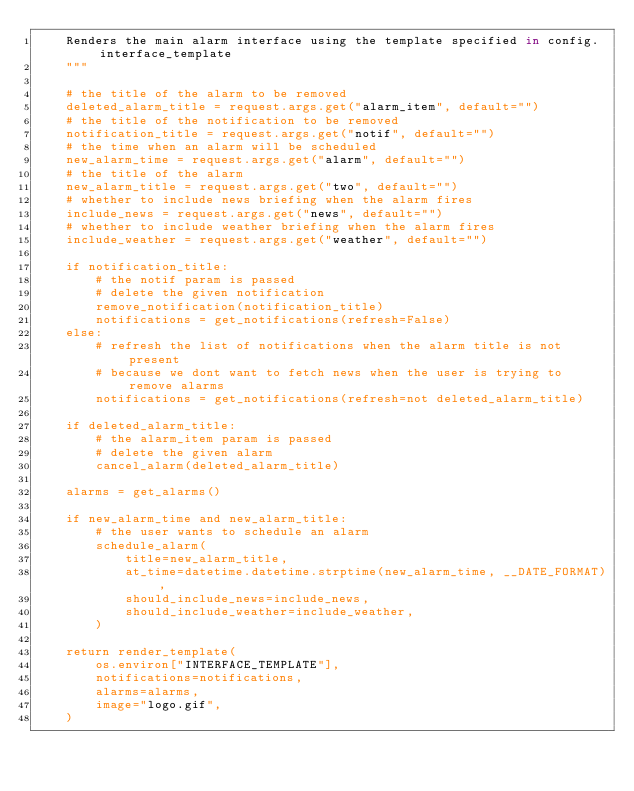Convert code to text. <code><loc_0><loc_0><loc_500><loc_500><_Python_>    Renders the main alarm interface using the template specified in config.interface_template
    """

    # the title of the alarm to be removed
    deleted_alarm_title = request.args.get("alarm_item", default="")
    # the title of the notification to be removed
    notification_title = request.args.get("notif", default="")
    # the time when an alarm will be scheduled
    new_alarm_time = request.args.get("alarm", default="")
    # the title of the alarm
    new_alarm_title = request.args.get("two", default="")
    # whether to include news briefing when the alarm fires
    include_news = request.args.get("news", default="")
    # whether to include weather briefing when the alarm fires
    include_weather = request.args.get("weather", default="")

    if notification_title:
        # the notif param is passed
        # delete the given notification
        remove_notification(notification_title)
        notifications = get_notifications(refresh=False)
    else:
        # refresh the list of notifications when the alarm title is not present
        # because we dont want to fetch news when the user is trying to remove alarms
        notifications = get_notifications(refresh=not deleted_alarm_title)

    if deleted_alarm_title:
        # the alarm_item param is passed
        # delete the given alarm
        cancel_alarm(deleted_alarm_title)

    alarms = get_alarms()

    if new_alarm_time and new_alarm_title:
        # the user wants to schedule an alarm
        schedule_alarm(
            title=new_alarm_title,
            at_time=datetime.datetime.strptime(new_alarm_time, __DATE_FORMAT),
            should_include_news=include_news,
            should_include_weather=include_weather,
        )

    return render_template(
        os.environ["INTERFACE_TEMPLATE"],
        notifications=notifications,
        alarms=alarms,
        image="logo.gif",
    )
</code> 